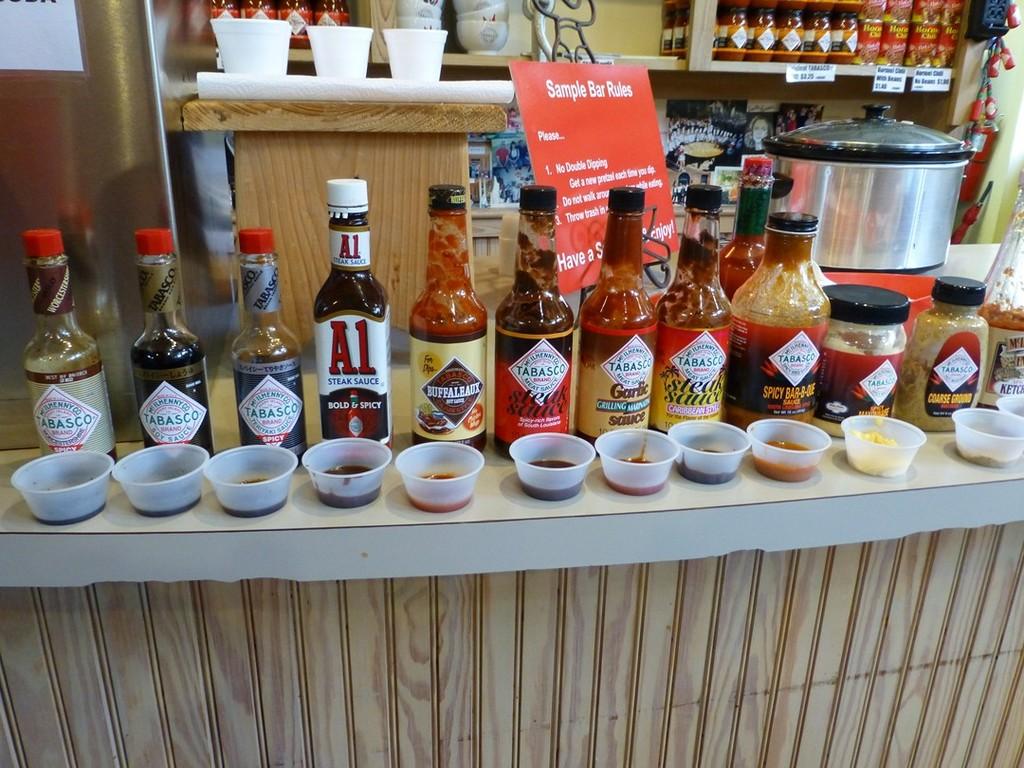What flavor is the a1 steak sauce?
Give a very brief answer. Bold & spicy. 